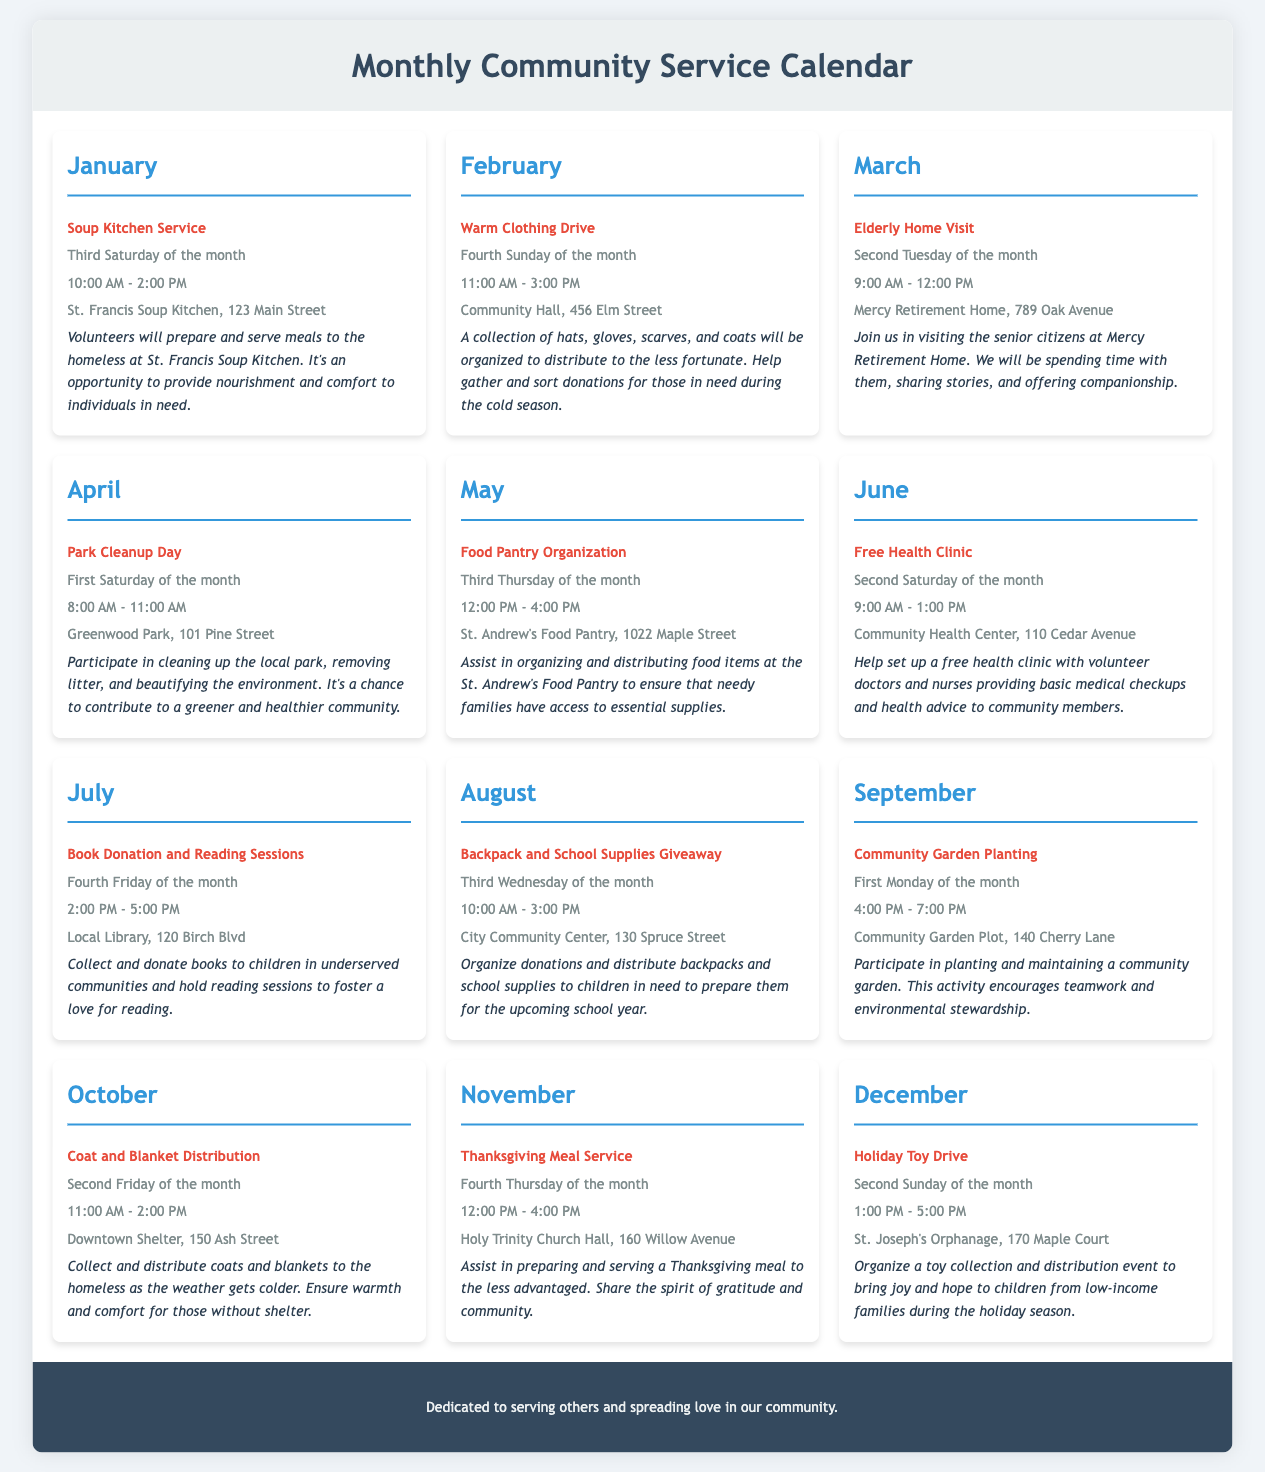What is the activity for January? The activity listed for January is "Soup Kitchen Service."
Answer: Soup Kitchen Service When is the Warm Clothing Drive scheduled? The Warm Clothing Drive is scheduled for the Fourth Sunday of the month.
Answer: Fourth Sunday of the month What time does the Park Cleanup Day start? The Park Cleanup Day starts at 8:00 AM.
Answer: 8:00 AM Where will the Thanksgiving Meal Service be held? The Thanksgiving Meal Service will be held at Holy Trinity Church Hall.
Answer: Holy Trinity Church Hall Which month includes the Free Health Clinic? The Free Health Clinic takes place in June.
Answer: June How many community service activities are listed in total? There are twelve community service activities listed, one for each month.
Answer: Twelve What type of activity is planned for March? The activity planned for March is an "Elderly Home Visit."
Answer: Elderly Home Visit On which day is the Holiday Toy Drive taking place? The Holiday Toy Drive is taking place on the Second Sunday of the month.
Answer: Second Sunday of the month What is the focus of the activities in December? The focus of the activities in December is on a toy collection and distribution event.
Answer: Toy collection and distribution event 